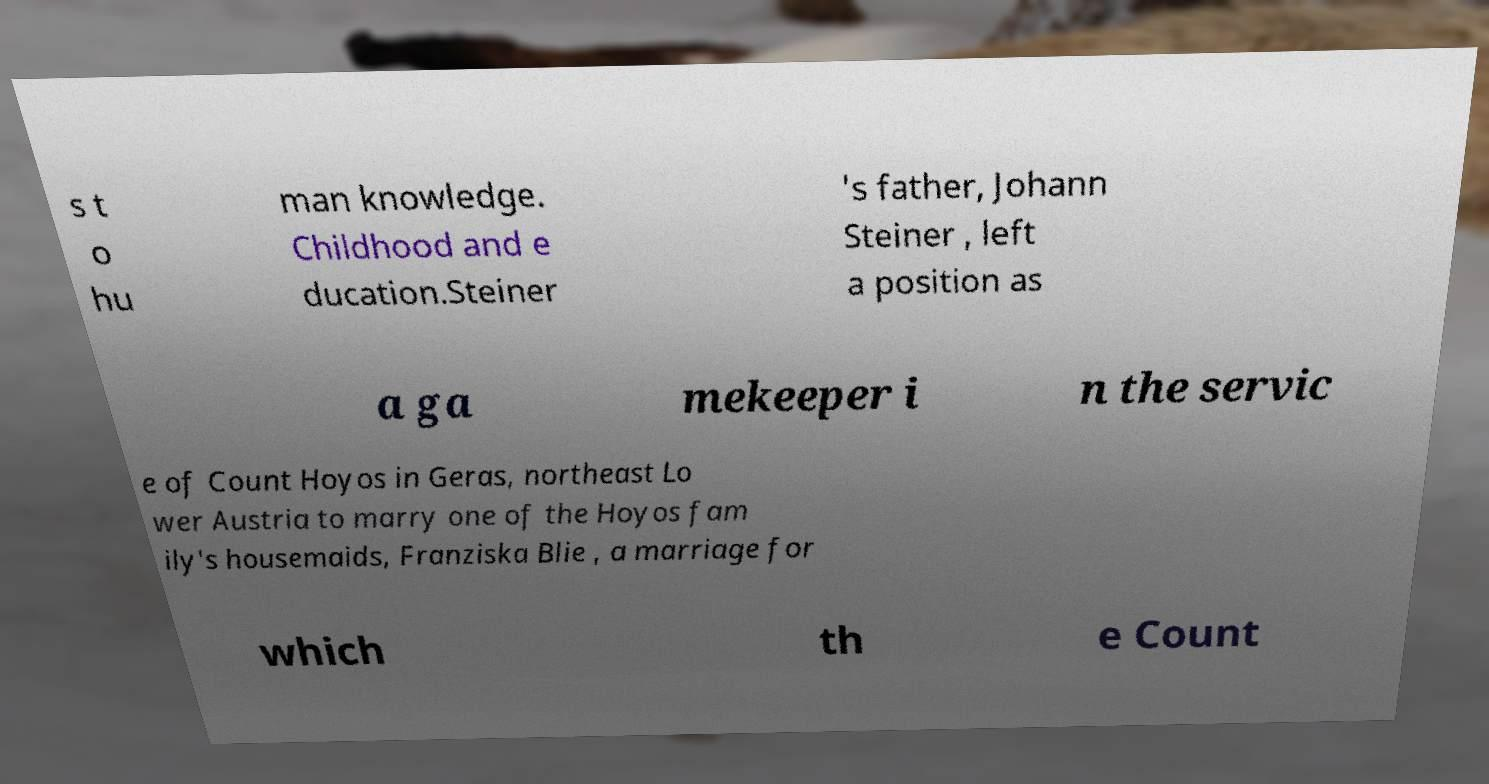Can you accurately transcribe the text from the provided image for me? s t o hu man knowledge. Childhood and e ducation.Steiner 's father, Johann Steiner , left a position as a ga mekeeper i n the servic e of Count Hoyos in Geras, northeast Lo wer Austria to marry one of the Hoyos fam ily's housemaids, Franziska Blie , a marriage for which th e Count 